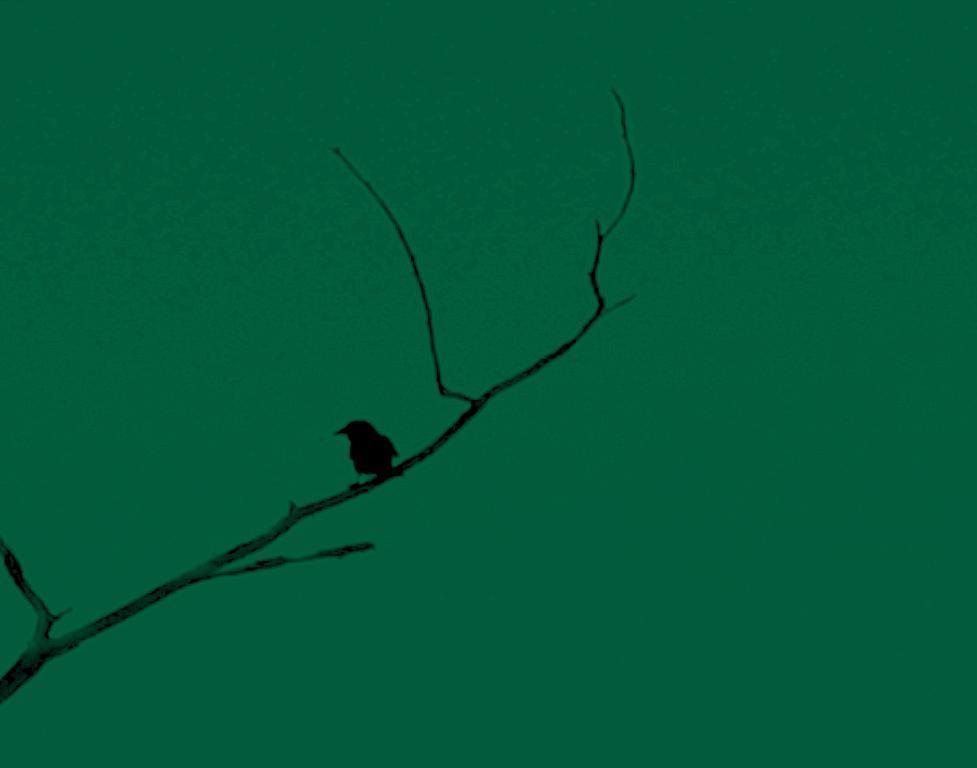How would you summarize this image in a sentence or two? In this image we can see a bird on the branch of a tree. In the background, we can see the sky. 